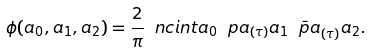<formula> <loc_0><loc_0><loc_500><loc_500>\phi ( a _ { 0 } , a _ { 1 } , a _ { 2 } ) = \frac { 2 } { \pi } \ n c i n t a _ { 0 } \ p a _ { ( \tau ) } a _ { 1 } \bar { \ p a } _ { ( \tau ) } a _ { 2 } .</formula> 